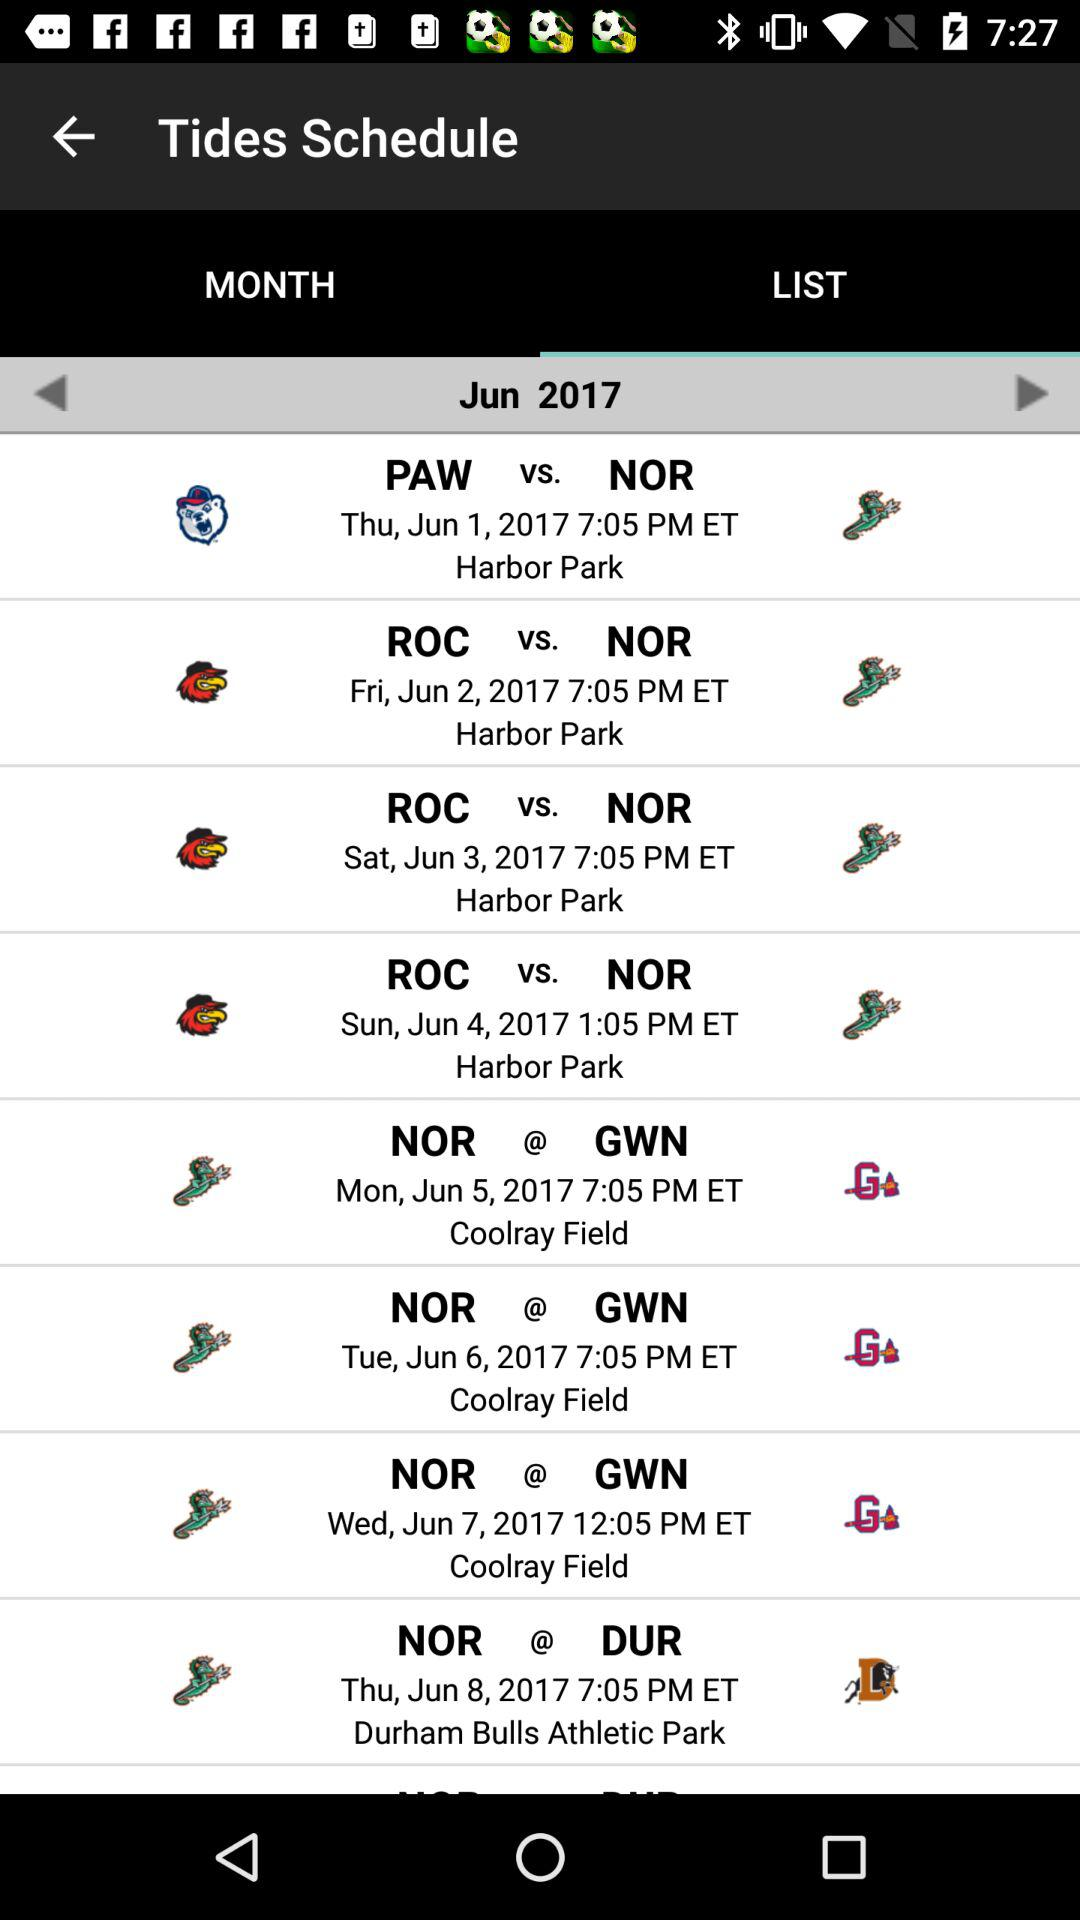Which tab is selected in the Tides schedule? The selected tab is list. 